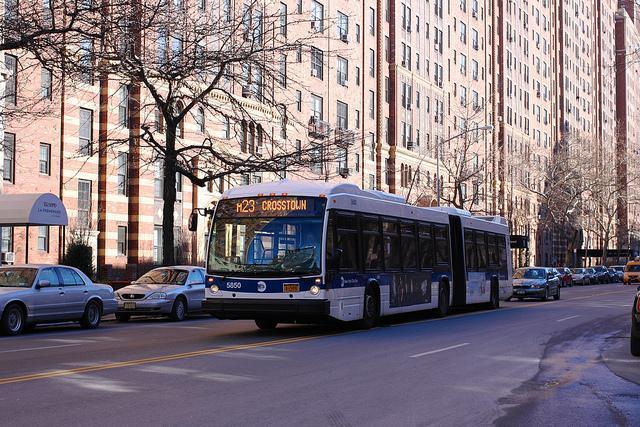What type of parking is shown?
Pick the correct solution from the four options below to address the question.
Options: Valet, lot, parallel, diagonal. Parallel. 